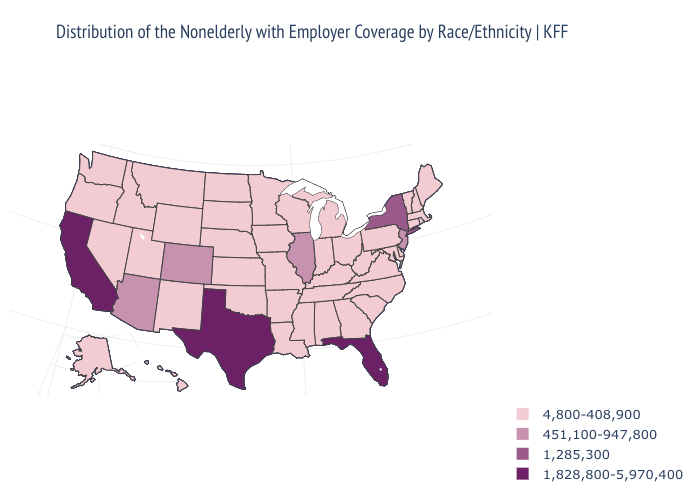Among the states that border Idaho , which have the lowest value?
Concise answer only. Montana, Nevada, Oregon, Utah, Washington, Wyoming. What is the value of Colorado?
Write a very short answer. 451,100-947,800. Name the states that have a value in the range 1,828,800-5,970,400?
Quick response, please. California, Florida, Texas. What is the value of Florida?
Concise answer only. 1,828,800-5,970,400. What is the highest value in states that border Wyoming?
Short answer required. 451,100-947,800. How many symbols are there in the legend?
Be succinct. 4. Among the states that border Tennessee , which have the highest value?
Be succinct. Alabama, Arkansas, Georgia, Kentucky, Mississippi, Missouri, North Carolina, Virginia. Does Illinois have the lowest value in the MidWest?
Answer briefly. No. Among the states that border New York , which have the lowest value?
Quick response, please. Connecticut, Massachusetts, Pennsylvania, Vermont. Among the states that border Michigan , which have the lowest value?
Concise answer only. Indiana, Ohio, Wisconsin. Name the states that have a value in the range 1,285,300?
Write a very short answer. New York. What is the lowest value in the MidWest?
Give a very brief answer. 4,800-408,900. Name the states that have a value in the range 1,828,800-5,970,400?
Concise answer only. California, Florida, Texas. Name the states that have a value in the range 1,285,300?
Quick response, please. New York. 